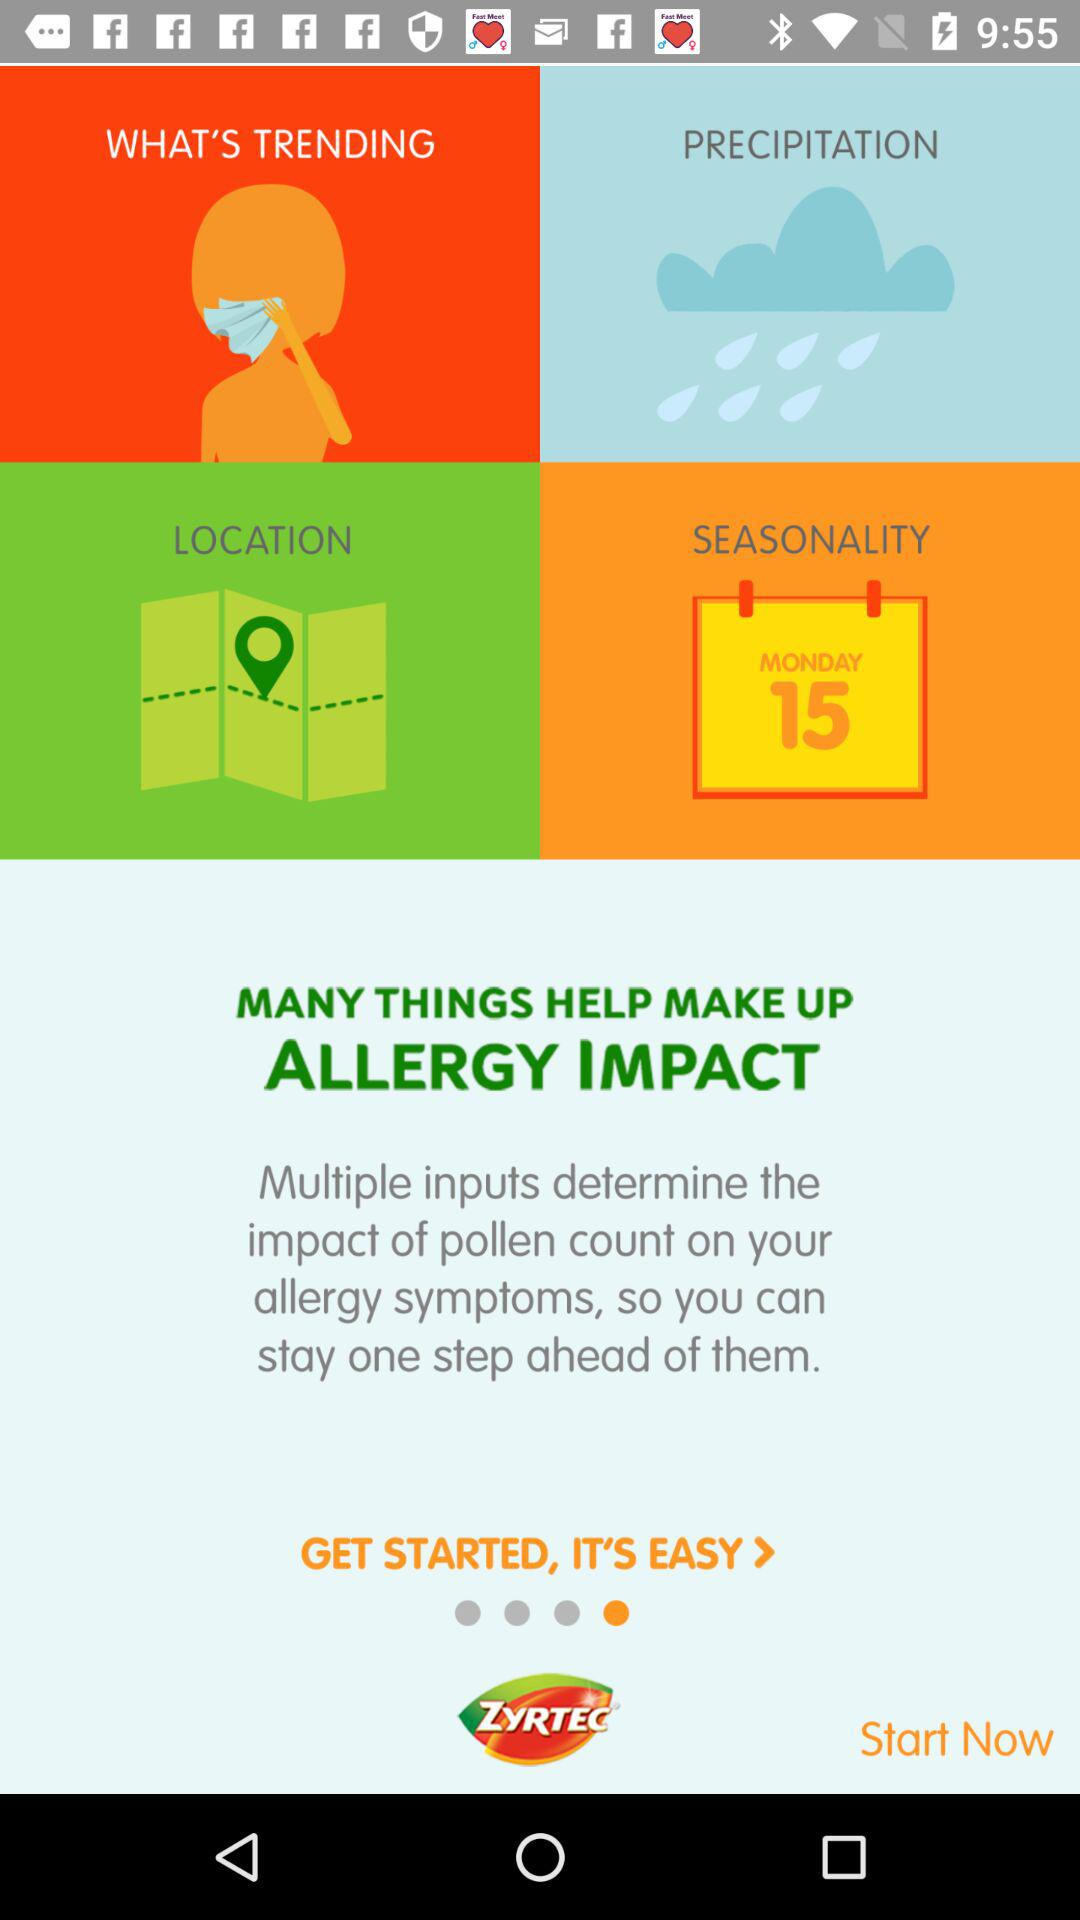What is the name of the application? The name of the application is "ZYRTEC® AllergyCast®". 